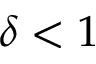Convert formula to latex. <formula><loc_0><loc_0><loc_500><loc_500>\delta < 1</formula> 